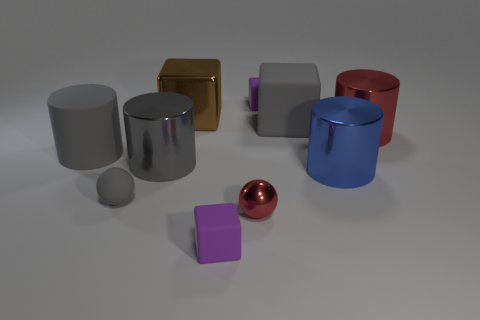Is there anything else that is the same shape as the large brown metal thing?
Offer a terse response. Yes. There is another metal object that is the same shape as the tiny gray thing; what is its color?
Provide a short and direct response. Red. What shape is the red metallic object behind the rubber cylinder?
Offer a terse response. Cylinder. Are there any purple objects on the left side of the large brown thing?
Your answer should be compact. No. Is there any other thing that has the same size as the gray rubber block?
Your answer should be very brief. Yes. What is the color of the big cylinder that is made of the same material as the tiny gray sphere?
Provide a succinct answer. Gray. There is a block in front of the big red object; is it the same color as the big cube behind the gray block?
Your response must be concise. No. How many spheres are either large gray objects or blue metallic things?
Provide a succinct answer. 0. Are there the same number of small purple rubber cubes left of the brown block and tiny matte objects?
Ensure brevity in your answer.  No. There is a small purple cube that is on the left side of the ball that is to the right of the gray rubber object in front of the large gray metal cylinder; what is its material?
Give a very brief answer. Rubber. 